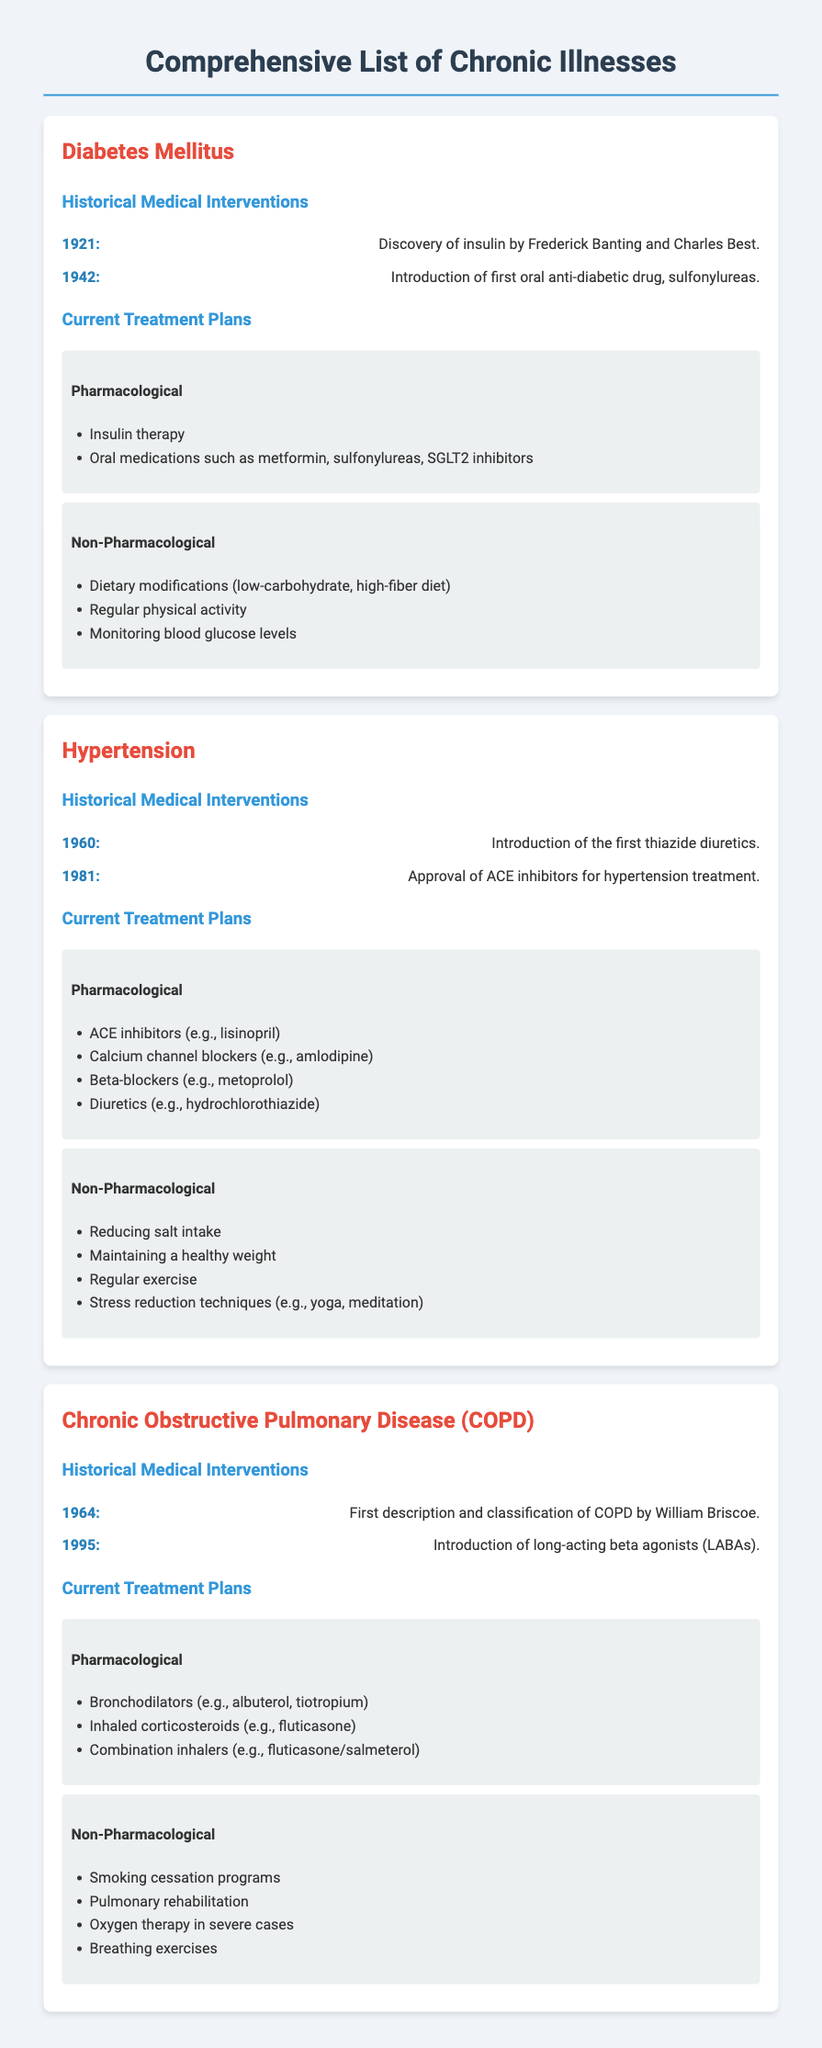What year was insulin discovered? The year insulin was discovered is explicitly mentioned in the historical medical interventions section.
Answer: 1921 What is a current pharmacological treatment for hypertension? The document lists specific pharmacological treatments under the current treatment plans for hypertension.
Answer: ACE inhibitors Which chronic illness was first described in 1964? The document states the first description and classification year for COPD, indicating which illness it refers to.
Answer: Chronic Obstructive Pulmonary Disease (COPD) What non-pharmacological recommendation is provided for managing diabetes? The current treatment plans for diabetes include various non-pharmacological recommendations mentioned in the document.
Answer: Dietary modifications How many years apart were the introduction of thiazide diuretics and ACE inhibitors? The years of introduction for both treatments are provided, and the difference can be calculated based on those years.
Answer: 21 years 